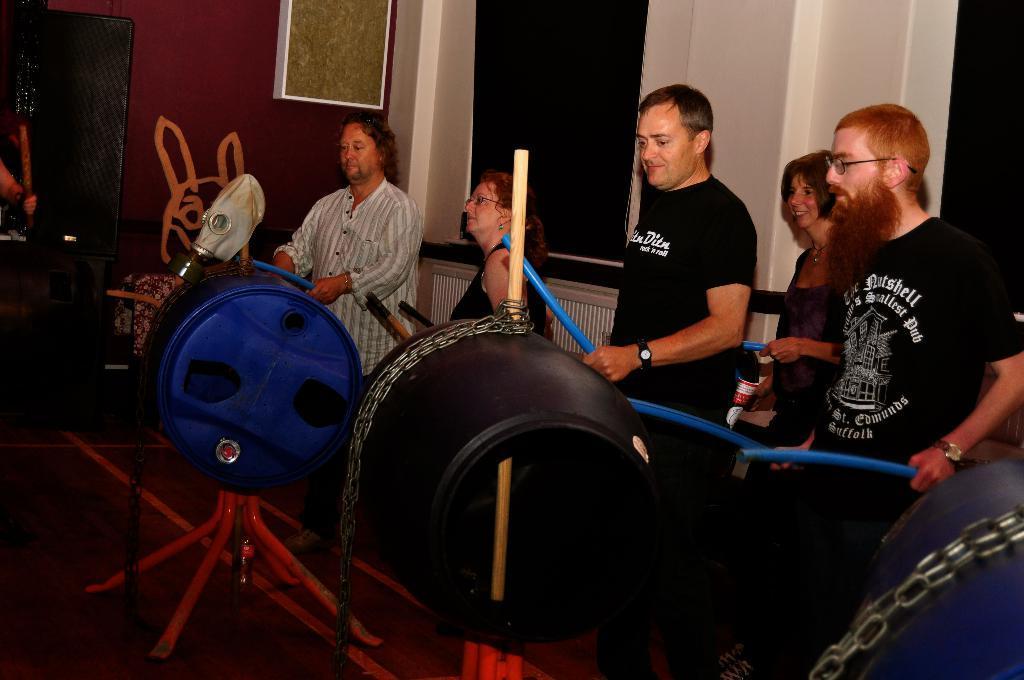How would you summarize this image in a sentence or two? In this image I see few people in which all of them are holding sticks in their hands and I see that these both of them are smiling and I see few things over here. In the background I see the wall which is of black, white and maroon in color and I see the path and I can also see the chains on these things. 